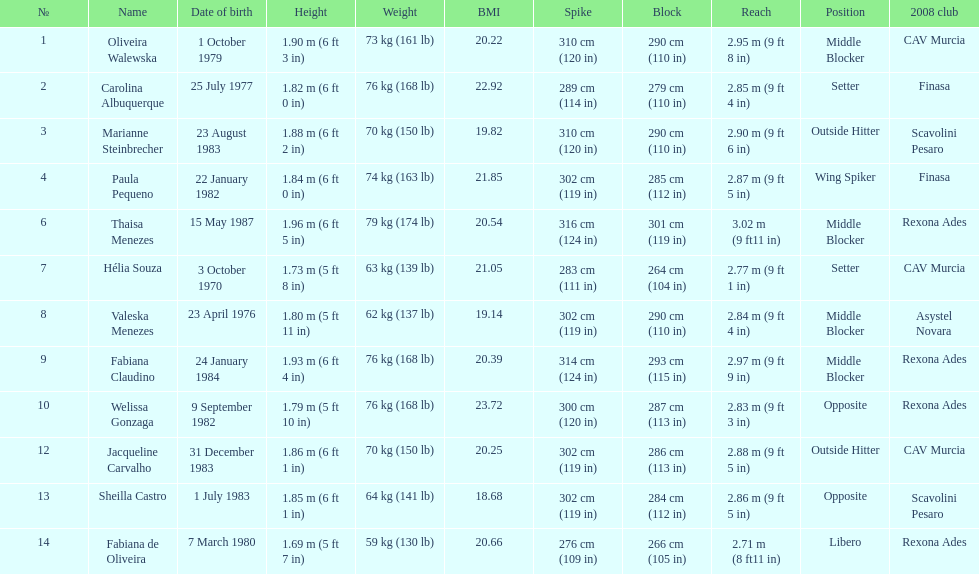Whose weight is the heaviest among the following: fabiana de oliveira, helia souza, or sheilla castro? Sheilla Castro. 